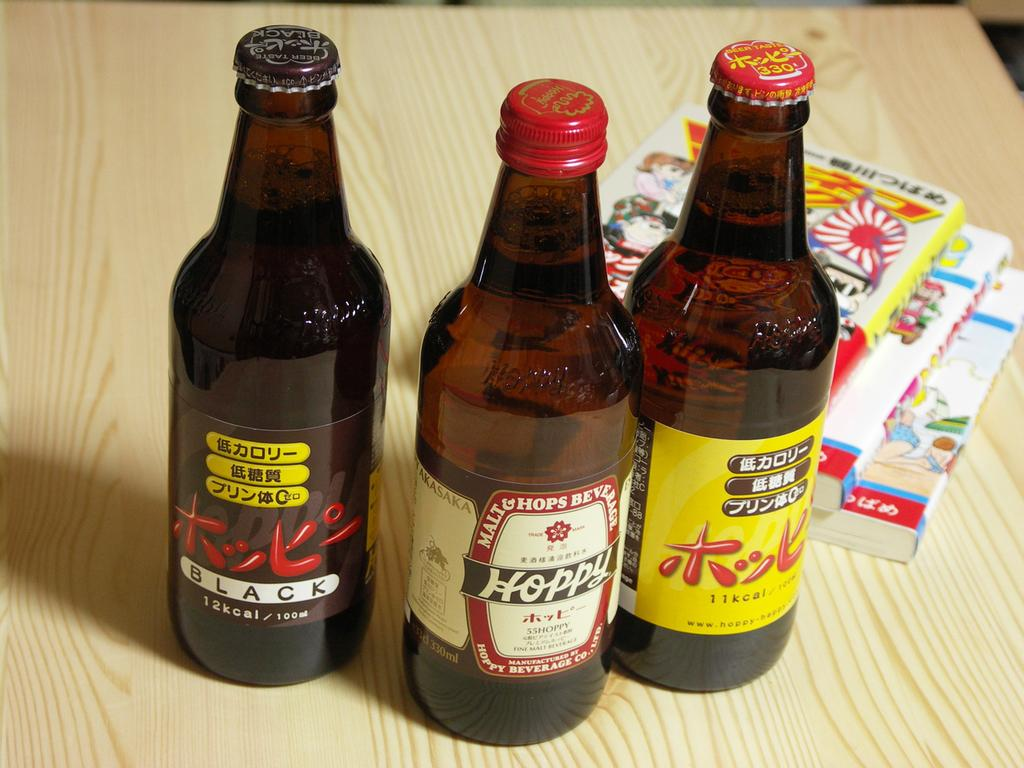<image>
Create a compact narrative representing the image presented. 3 different drinks in japanese and one saying black 